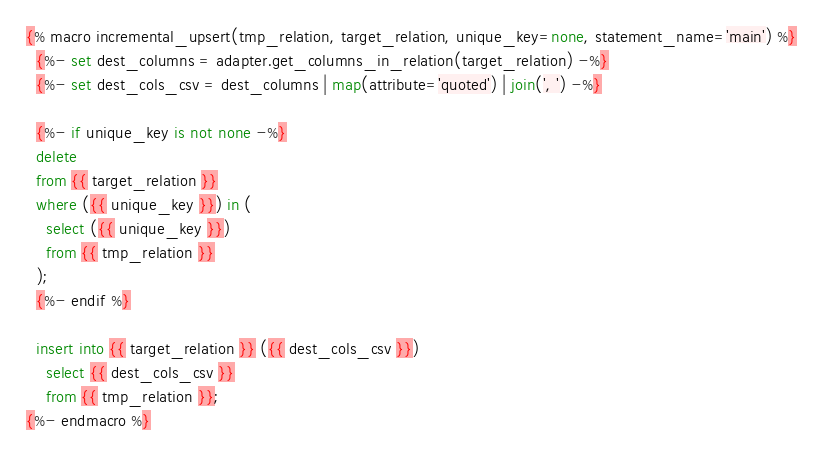Convert code to text. <code><loc_0><loc_0><loc_500><loc_500><_SQL_>{% macro incremental_upsert(tmp_relation, target_relation, unique_key=none, statement_name='main') %}
  {%- set dest_columns = adapter.get_columns_in_relation(target_relation) -%}
  {%- set dest_cols_csv = dest_columns | map(attribute='quoted') | join(', ') -%}

  {%- if unique_key is not none -%}
  delete
  from {{ target_relation }}
  where ({{ unique_key }}) in (
    select ({{ unique_key }})
    from {{ tmp_relation }}
  );
  {%- endif %}

  insert into {{ target_relation }} ({{ dest_cols_csv }})
    select {{ dest_cols_csv }}
    from {{ tmp_relation }};
{%- endmacro %}</code> 